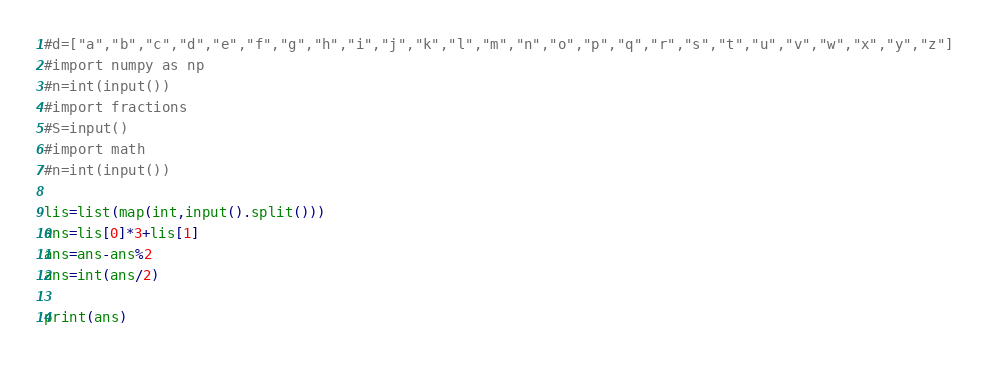<code> <loc_0><loc_0><loc_500><loc_500><_Python_>#d=["a","b","c","d","e","f","g","h","i","j","k","l","m","n","o","p","q","r","s","t","u","v","w","x","y","z"]
#import numpy as np
#n=int(input())
#import fractions
#S=input()
#import math
#n=int(input())

lis=list(map(int,input().split()))
ans=lis[0]*3+lis[1]
ans=ans-ans%2
ans=int(ans/2)

print(ans)
</code> 